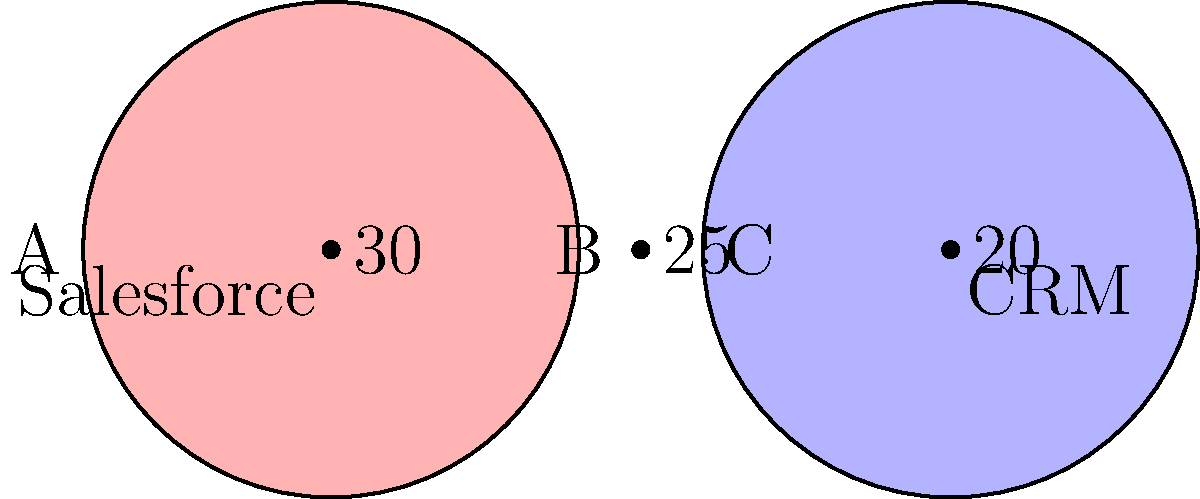Given the Venn diagram representing data fields in Salesforce and a CRM system, with 30 fields unique to Salesforce (A), 25 fields shared between both systems (B), and 20 fields unique to the CRM (C), what percentage of total fields should be prioritized for optimization to ensure maximum efficiency in data synchronization? To determine the percentage of fields to prioritize for optimization, we need to follow these steps:

1. Calculate the total number of fields:
   Total fields = A + B + C = 30 + 25 + 20 = 75

2. Identify the fields that require synchronization:
   - Shared fields (B) are already in both systems but may need optimization
   - Fields unique to Salesforce (A) and CRM (C) need to be synced to the other system

3. Calculate the number of fields to be optimized:
   Fields to optimize = B + (A + C) / 2
   This approach prioritizes shared fields and half of the unique fields, assuming not all unique fields need to be synced.

   Fields to optimize = 25 + (30 + 20) / 2 = 25 + 25 = 50

4. Calculate the percentage:
   Percentage to optimize = (Fields to optimize / Total fields) * 100
   Percentage to optimize = (50 / 75) * 100 = 66.67%

Therefore, approximately 66.67% of the total fields should be prioritized for optimization to ensure maximum efficiency in data synchronization between Salesforce and the CRM system.
Answer: 66.67% 